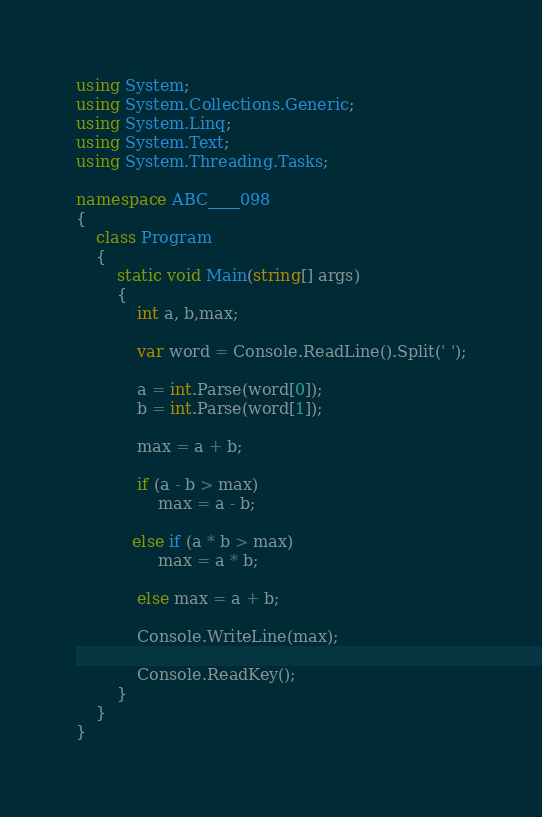Convert code to text. <code><loc_0><loc_0><loc_500><loc_500><_C#_>using System;
using System.Collections.Generic;
using System.Linq;
using System.Text;
using System.Threading.Tasks;

namespace ABC____098
{
    class Program
    {
        static void Main(string[] args)
        {
            int a, b,max;

            var word = Console.ReadLine().Split(' ');

            a = int.Parse(word[0]);
            b = int.Parse(word[1]);

            max = a + b;

            if (a - b > max)
                max = a - b;

           else if (a * b > max)
                max = a * b;

            else max = a + b;
                    
            Console.WriteLine(max);

            Console.ReadKey();
        }
    }
}</code> 